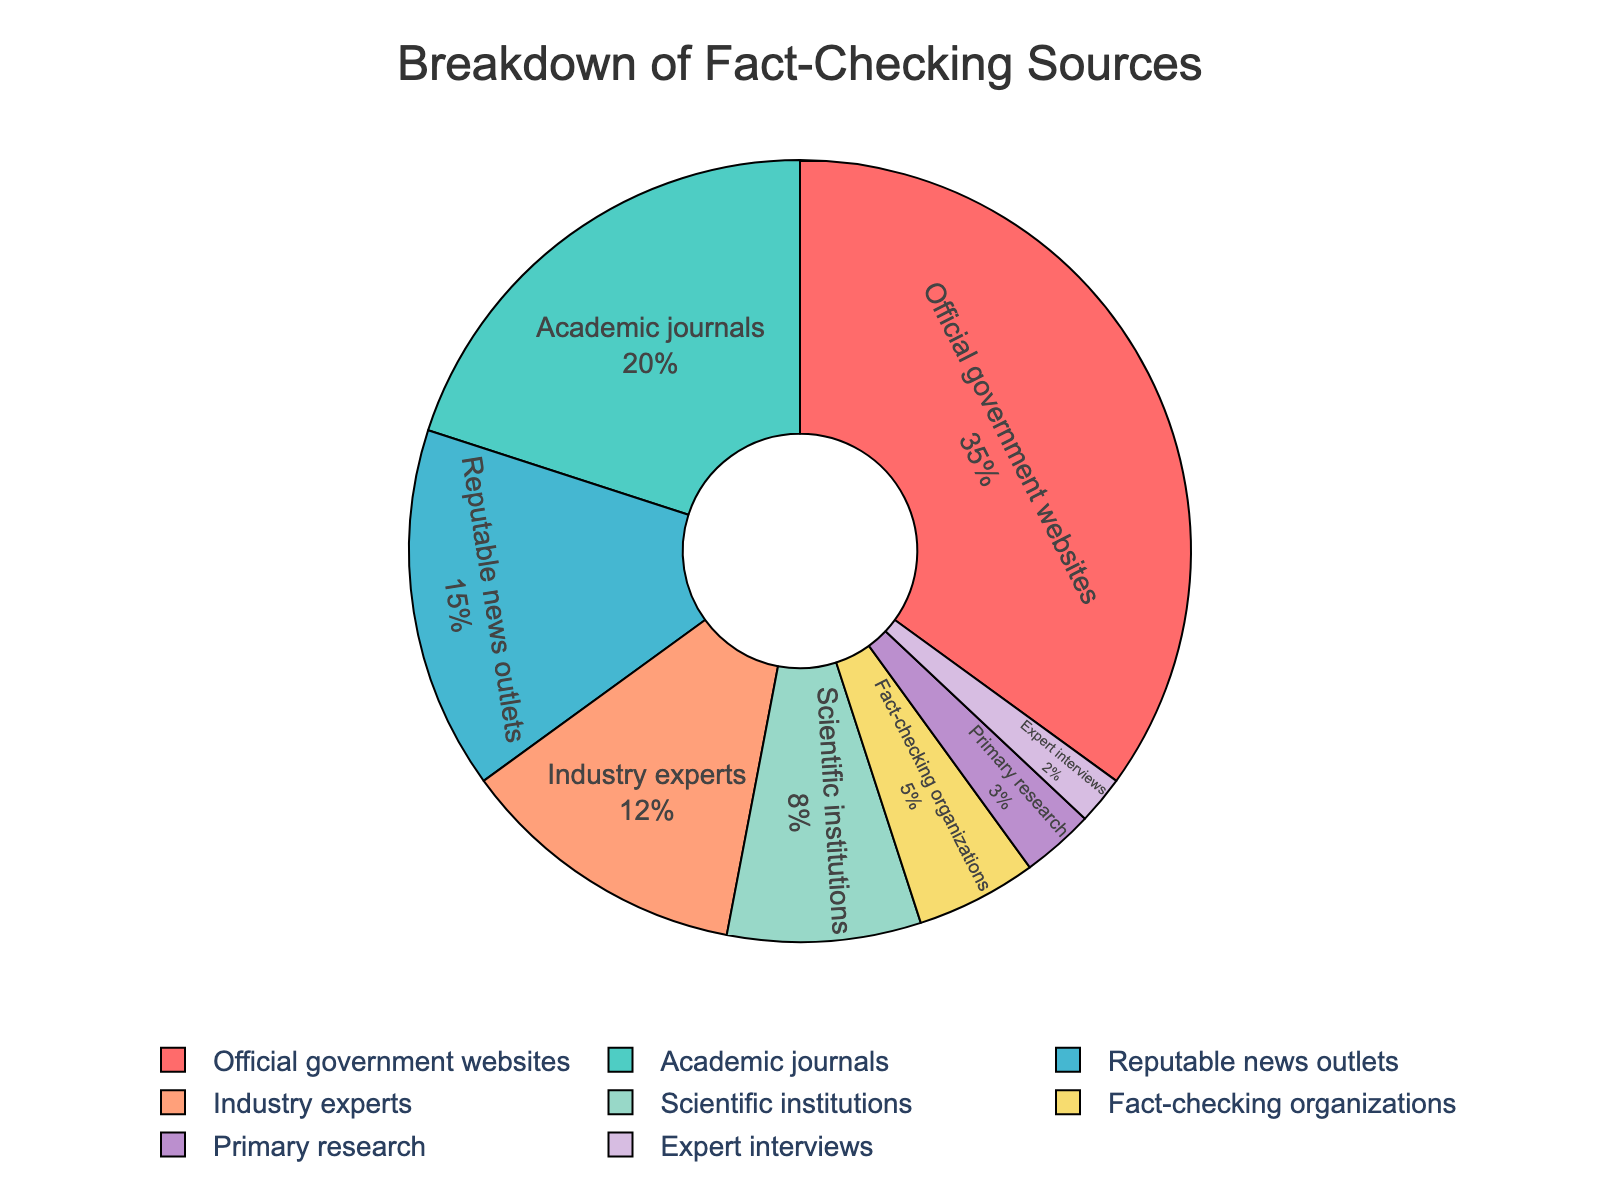What is the largest segment in the pie chart? The largest segment in a pie chart can be determined by identifying the segment that covers the most area. In this case, it is "Official government websites" with a percentage of 35%.
Answer: Official government websites Which two sources have the smallest percentages? To find the two smallest percentages, look for the segments that occupy the least area in the pie chart. These are "Expert interviews" at 2% and "Primary research" at 3%.
Answer: Expert interviews and Primary research How does the percentage of information from academic journals compare to reputable news outlets? To compare the percentages, look at the slices for "Academic journals" and "Reputable news outlets". Academic journals account for 20% and reputable news outlets account for 15%. By comparison, academic journals contribute a larger percentage.
Answer: Academic journals have a higher percentage (20%) than reputable news outlets (15%) What is the combined percentage of sources from scientific institutions and industry experts? To find the combined percentage, add the two individual percentages: "Scientific institutions" (8%) and "Industry experts" (12%). So, 8 + 12 = 20%.
Answer: 20% Are the fact-checking organizations contributing more than scientific institutions? To answer this, compare the percentages of "Fact-checking organizations" and "Scientific institutions". Fact-checking organizations contribute 5%, whereas scientific institutions contribute 8%. Hence, scientific institutions contribute more.
Answer: No What is the percentage difference between fact-checking organizations and primary research? To find the difference, subtract the percentage of "Primary research" from "Fact-checking organizations". That is, 5% - 3% = 2%.
Answer: 2% Which segment is represented by a segment colored in blue? The blue color in the plot refers to "Academic journals", which is 20% of the pie chart.
Answer: Academic journals What is the sum of the percentages contributed by reputable news outlets and expert interviews combined? Add the percentage for "Reputable news outlets" (15%) and "Expert interviews" (2%). So, 15 + 2 = 17%.
Answer: 17% By how much does the percentage for industry experts exceed that of primary research? To determine the excess, subtract the percentage of "Primary research" from "Industry experts". So, 12% - 3% = 9%.
Answer: 9% Given that official government websites contribute 35%, how much more do they contribute than academic journals? Subtract the percentage for "Academic journals" from "Official government websites": 35% - 20% = 15%.
Answer: 15% 